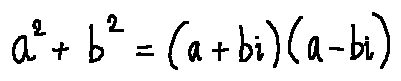Convert formula to latex. <formula><loc_0><loc_0><loc_500><loc_500>a ^ { 2 } + b ^ { 2 } = ( a + b i ) ( a - b i )</formula> 